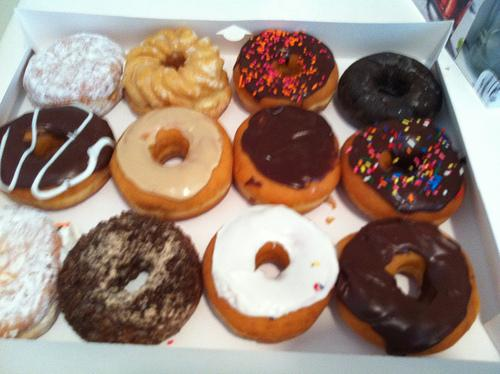What are the emotions or feeling that could be associated with the image? The image might evoke feelings of happiness, satisfaction, and indulgence due to the delicious variety of donuts on display. Enumerate the types of frostings and toppings on the donuts. The frostings include chocolate, white, maple, and glaze, while the toppings consist of sprinkles, confectioner sugar, and powdered sugar. How would you describe the quality of the image in terms of details and clarity? The image quality is high, with clear details in the donuts' textures, colors, and sizes, allowing viewers to appreciate the various flavors and styles. Count the total number of donuts in the image. There are twelve donuts in the image. Analyze the position of the objects, revealing any possible interactions between them. The donuts are tightly placed next to each other in the box and appear to slightly overlap, but there are no notable interactions between them. How many donuts can be seen in the image and what are the main flavor varieties? There are twelve donuts in the image, featuring flavors like chocolate, maple, and jelly-filled. In a few sentences, narrate the image content in detail. The image features a white box filled with twelve diverse donuts. Each donut varies in flavor, frosting, and topping, including chocolate, maple, and sprinkles. Some donuts possess specific design elements such as swirls and powdered sugar. Identify some unique characteristics of the donuts in the image. Some unique characteristics include white swirls on the chocolate frosting, powdered sugar dusting, blue yellow pink white and orange sprinkles, and the cruller type donut. Identify the primary focus of the image, including the type of objects it contains. The image primarily focuses on a box containing a dozen assorted donuts with different flavors, frostings, and toppings. Can you tell if there is any complex reasoning required to understand the image? No complex reasoning is necessary, as the image shows a simple and straightforward scene of a box with a dozen assorted donuts. Could you please point out the slice of pizza hidden among the donuts in the center of the box? The image only consists of donuts and there is no pizza slice present. This instruction is misleading because it asks the user to find something unrelated and not present in the image. Please show me the row of eclairs that are resting on the top edge of the box. The image contains only donuts and no eclairs. This instruction is misleading as it seeks information about a non-existent object and implies the presence of a row of eclairs. Tell me the spot where the blueberry muffin intersects with a donut in the middle of the box. The image does not contain any muffins, only donuts. This instruction is misleading since it includes a reference to an item not present in the image, along with a spatial condition that cannot exist. Identify the donut with green frosting and candy eyeballs on top, located on the left side of the box. There are no donuts with green frosting and candy eyeballs in the image. This instruction is misleading since it describes a non-existent object with specific characteristics. Find the triangular pastry with strawberry icing in the bottom right corner of the box. The image only contains round donuts and no triangular pastry is present. This instruction is misleading as it asks the user to find a non-existent object. What percentage of the donuts in the box have a square shape? All the donuts in the image are round, so there are no square-shaped donuts. This instruction is misleading as it asks the user to calculate a percentage for a non-existent property. 